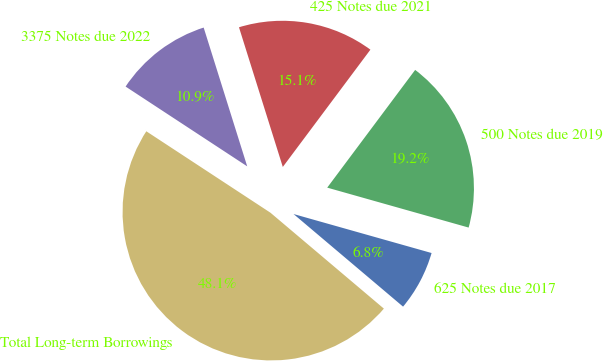Convert chart. <chart><loc_0><loc_0><loc_500><loc_500><pie_chart><fcel>625 Notes due 2017<fcel>500 Notes due 2019<fcel>425 Notes due 2021<fcel>3375 Notes due 2022<fcel>Total Long-term Borrowings<nl><fcel>6.79%<fcel>19.17%<fcel>15.05%<fcel>10.92%<fcel>48.07%<nl></chart> 